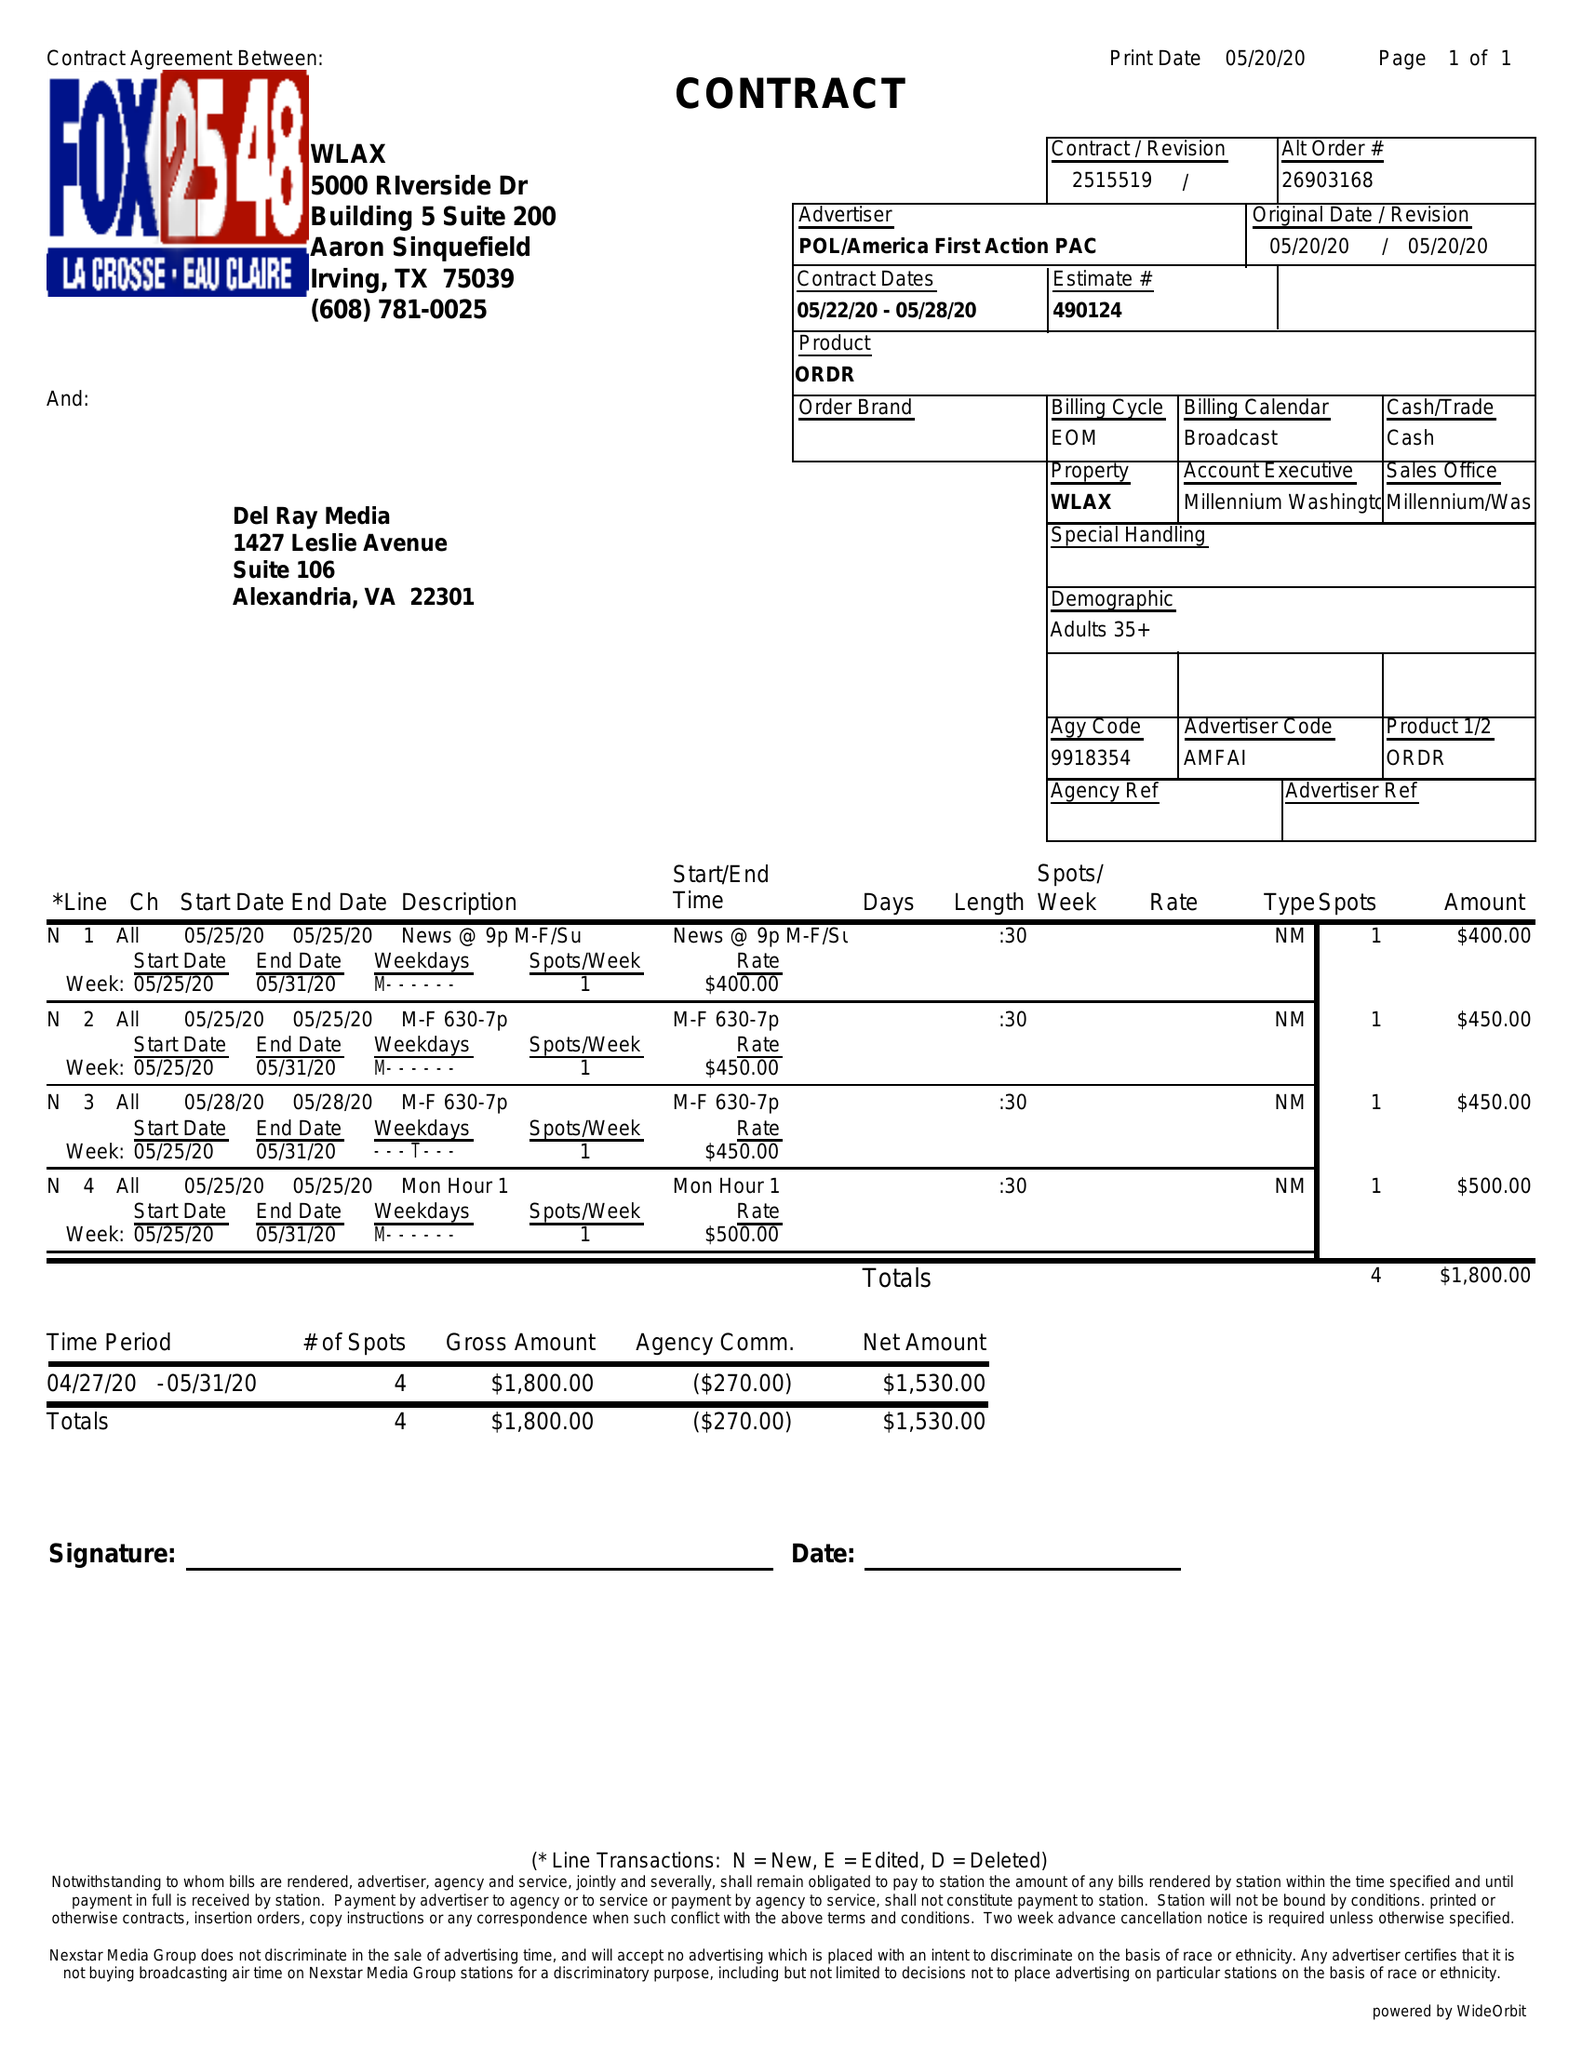What is the value for the advertiser?
Answer the question using a single word or phrase. POL/AMERICAFIRSTACTIONPAC 